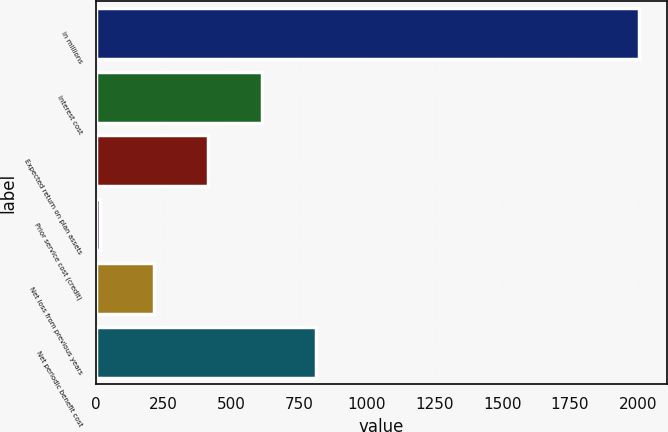Convert chart to OTSL. <chart><loc_0><loc_0><loc_500><loc_500><bar_chart><fcel>in millions<fcel>Interest cost<fcel>Expected return on plan assets<fcel>Prior service cost (credit)<fcel>Net loss from previous years<fcel>Net periodic benefit cost<nl><fcel>2006<fcel>613<fcel>414<fcel>16<fcel>215<fcel>812<nl></chart> 